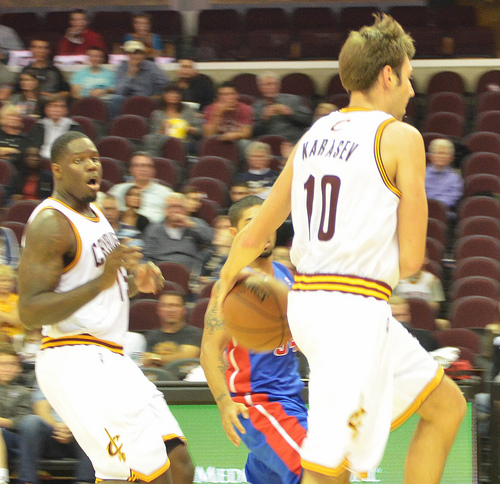<image>
Is the air in the basketball? Yes. The air is contained within or inside the basketball, showing a containment relationship. Is the ball next to the man? Yes. The ball is positioned adjacent to the man, located nearby in the same general area. Is the ball in front of the man? Yes. The ball is positioned in front of the man, appearing closer to the camera viewpoint. 